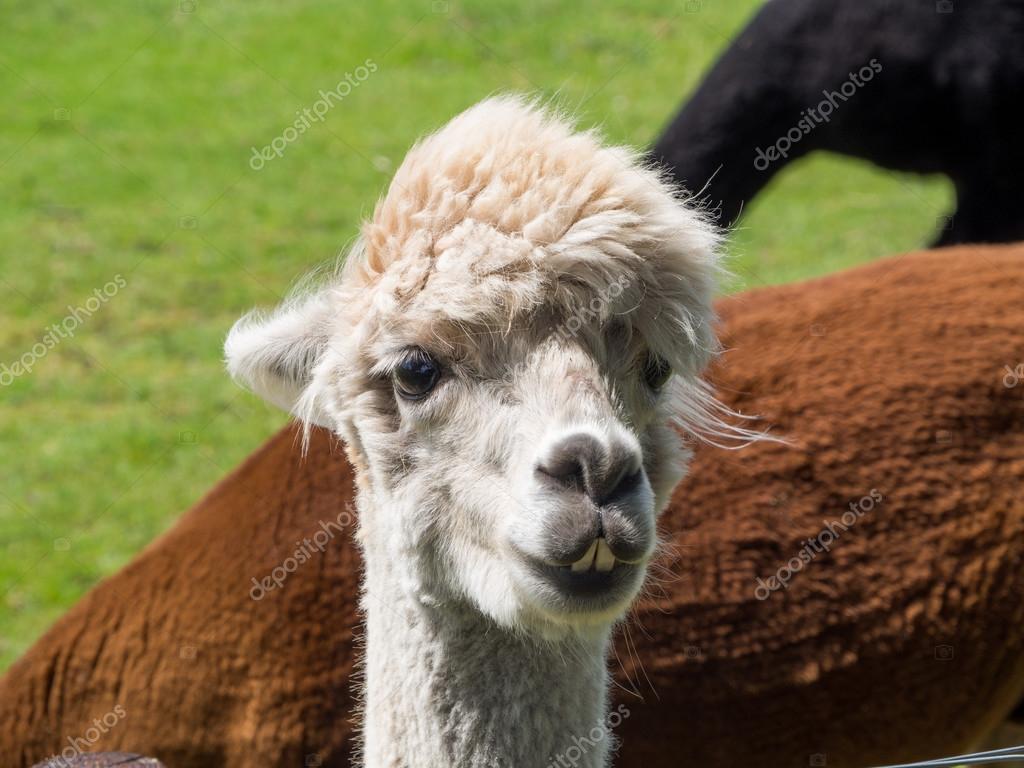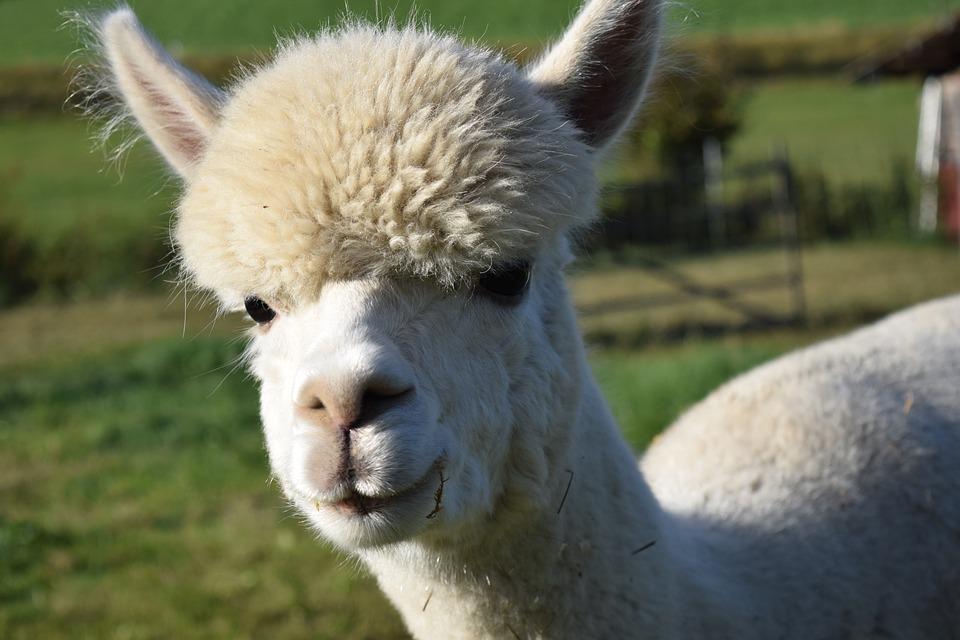The first image is the image on the left, the second image is the image on the right. For the images displayed, is the sentence "The head of one llama can seen in each image and none of them have brown fur." factually correct? Answer yes or no. Yes. The first image is the image on the left, the second image is the image on the right. For the images shown, is this caption "Four llama eyes are visible." true? Answer yes or no. Yes. 